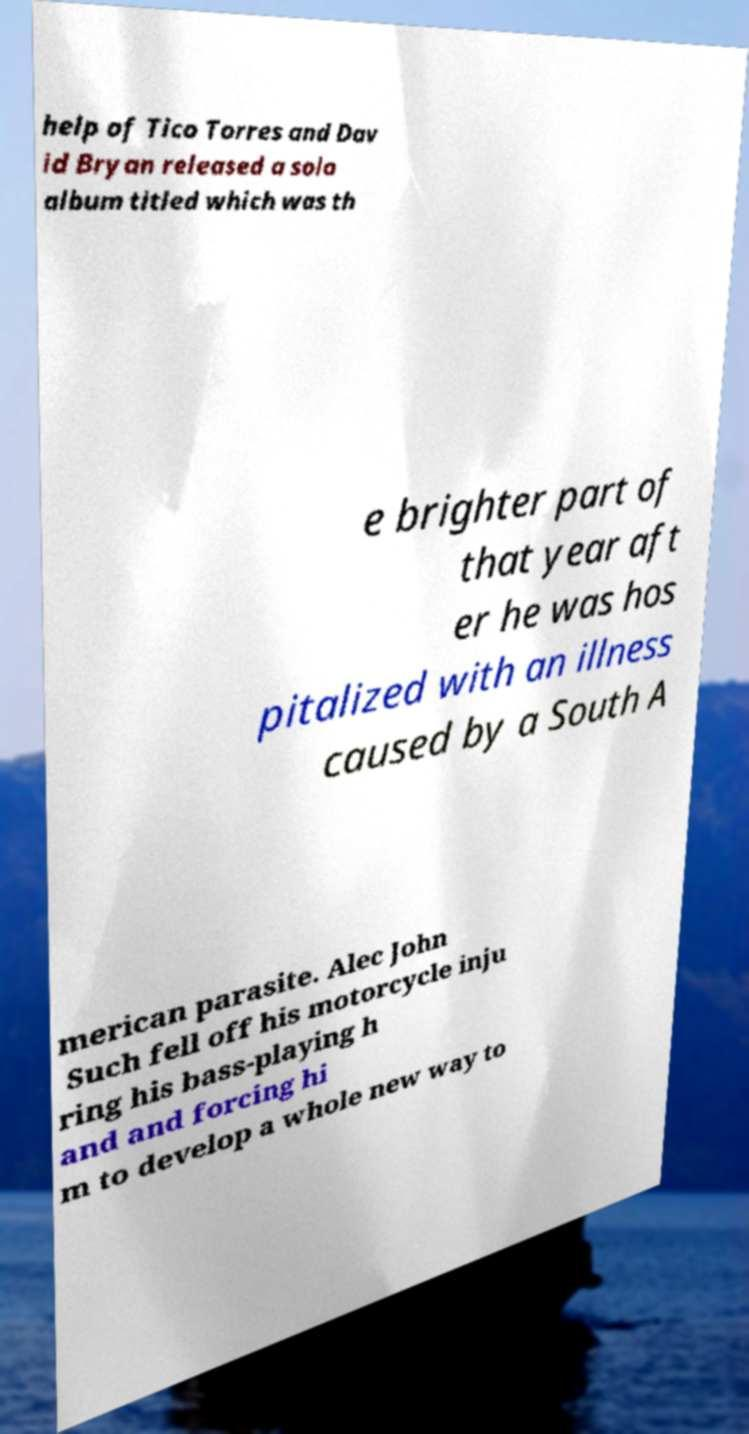Could you extract and type out the text from this image? help of Tico Torres and Dav id Bryan released a solo album titled which was th e brighter part of that year aft er he was hos pitalized with an illness caused by a South A merican parasite. Alec John Such fell off his motorcycle inju ring his bass-playing h and and forcing hi m to develop a whole new way to 